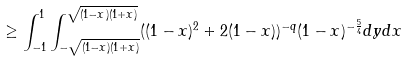<formula> <loc_0><loc_0><loc_500><loc_500>\geq \int _ { - 1 } ^ { 1 } \int _ { - \sqrt { ( 1 - x ) ( 1 + x ) } } ^ { \sqrt { ( 1 - x ) ( 1 + x ) } } ( ( 1 - x ) ^ { 2 } + 2 ( 1 - x ) ) ^ { - q } ( 1 - x ) ^ { - \frac { 5 } { 4 } } d y d x</formula> 